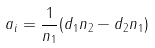Convert formula to latex. <formula><loc_0><loc_0><loc_500><loc_500>\ a _ { i } = \frac { 1 } { n _ { 1 } } ( d _ { 1 } n _ { 2 } - d _ { 2 } n _ { 1 } )</formula> 